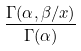<formula> <loc_0><loc_0><loc_500><loc_500>\frac { \Gamma ( \alpha , \beta / x ) } { \Gamma ( \alpha ) }</formula> 